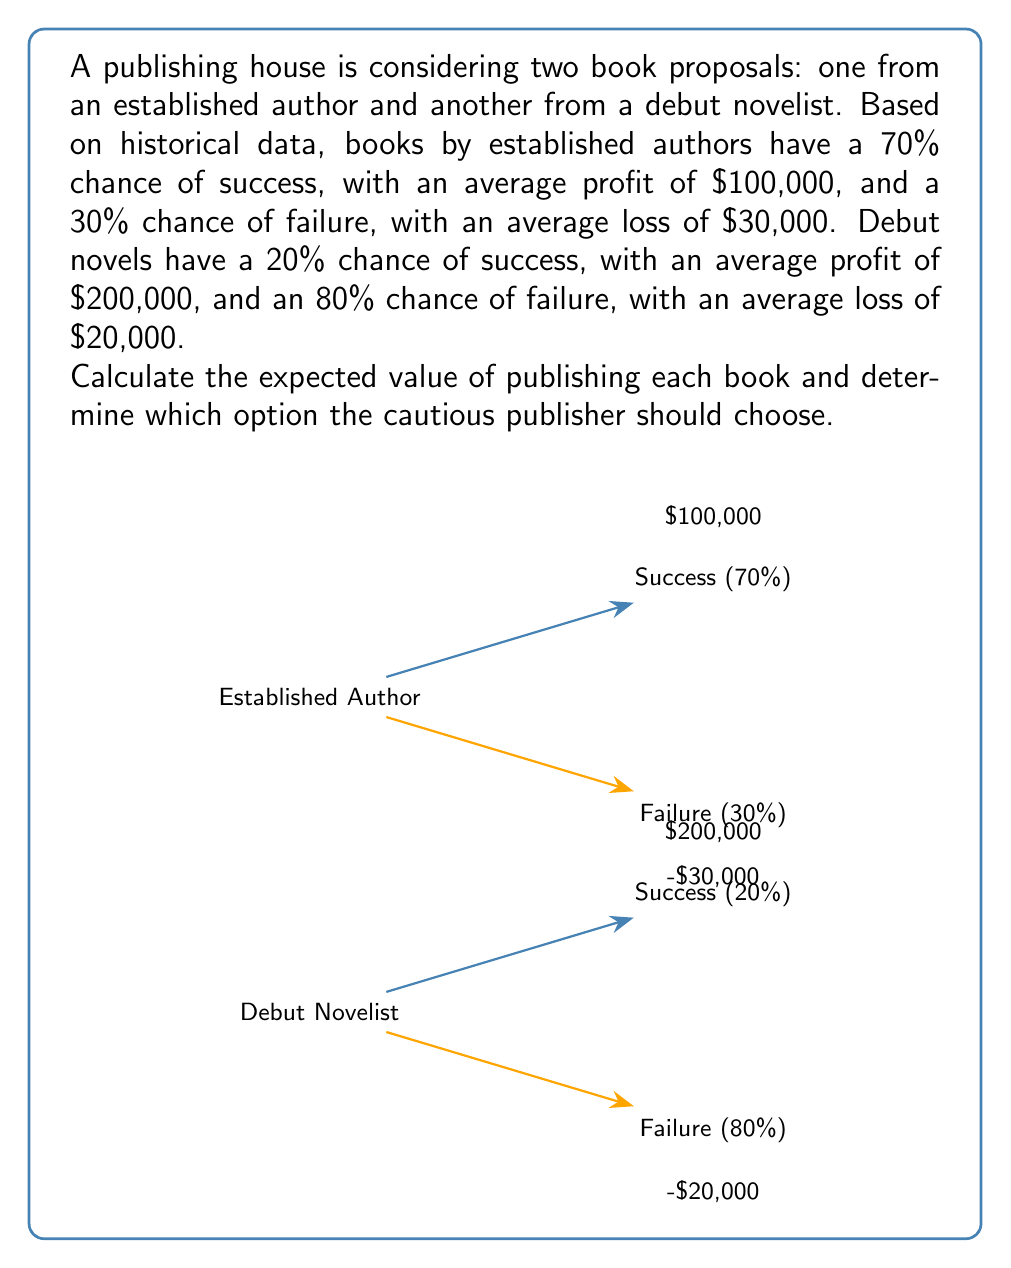Can you solve this math problem? To solve this problem, we need to calculate the expected value for each option:

1. Expected Value for Established Author:
   Let $E_E$ be the expected value for the established author.
   $$E_E = (0.70 \times \$100,000) + (0.30 \times (-\$30,000))$$
   $$E_E = \$70,000 - \$9,000 = \$61,000$$

2. Expected Value for Debut Novelist:
   Let $E_D$ be the expected value for the debut novelist.
   $$E_D = (0.20 \times \$200,000) + (0.80 \times (-\$20,000))$$
   $$E_D = \$40,000 - \$16,000 = \$24,000$$

3. Comparison:
   The expected value for the established author ($61,000) is higher than that of the debut novelist ($24,000).

4. Decision:
   Given the persona of a cautious publisher preferring established authors, and the higher expected value, the publisher should choose to publish the book by the established author.
Answer: Publish the established author's book (Expected Value: $61,000) 